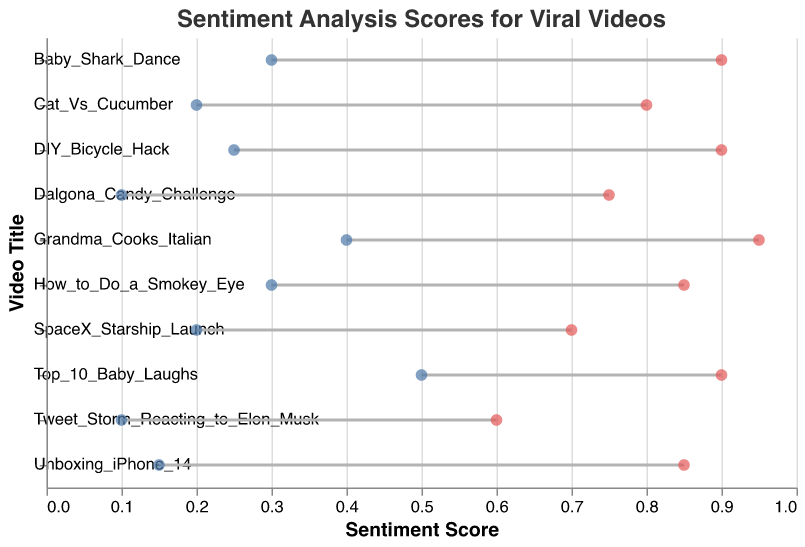Which video has the highest maximum sentiment score? Look for the highest point on the horizontal axis labeled as maximum sentiment scores, which is at 0.95. The corresponding video title is "Grandma Cooks Italian".
Answer: Grandma Cooks Italian What is the sentiment score range for the video "Unboxing iPhone 14" on YouTube? Locate "Unboxing iPhone 14" on the y-axis and note the minimum sentiment score (0.15) and the maximum sentiment score (0.85). The range is from 0.15 to 0.85.
Answer: 0.15 to 0.85 How many videos have a maximum sentiment score above 0.9? Identify all points on the horizontal axis for maximum sentiment score that are greater than 0.9. The videos are: "Grandma Cooks Italian" with a score of 0.95 and "Baby Shark Dance" with a score of 0.9.
Answer: 2 Which platform hosts the video with the smallest range in sentiment scores? Calculate the range (maximum minus minimum) for each video. "Tweet Storm Reacting to Elon Musk" on Twitter has a range of 0.6 - 0.1 = 0.5, which is the smallest.
Answer: Twitter Compare the sentiment score ranges of "DIY Bicycle Hack" on Instagram and "SpaceX Starship Launch" on Twitter. Which has a wider range? Calculate the range for both videos. "DIY Bicycle Hack" has a range of 0.9 - 0.25 = 0.65, and "SpaceX Starship Launch" has a range of 0.7 - 0.2 = 0.5. "DIY Bicycle Hack" has a wider range.
Answer: DIY Bicycle Hack Which video has the highest minimum sentiment score? Look for the highest point on the horizontal axis labeled as minimum sentiment scores, which is at 0.5. The corresponding video title is "Top 10 Baby Laughs".
Answer: Top 10 Baby Laughs Find the average of the minimum sentiment scores for YouTube videos. Sum the minimum sentiment scores of "Unboxing iPhone 14" (0.15) and "Baby Shark Dance" (0.3), then divide by the number of videos: (0.15 + 0.3) / 2 = 0.225.
Answer: 0.225 What is the difference in maximum sentiment score between "Dalgona Candy Challenge" on TikTok and "How to Do a Smokey Eye" on Instagram? Subtract the maximum sentiment score of "Dalgona Candy Challenge" (0.75) from "How to Do a Smokey Eye" (0.85): 0.85 - 0.75 = 0.1.
Answer: 0.1 Which platform has the most videos with a minimum sentiment score of at least 0.3? Count the number of videos on each platform with minimum sentiment scores of at least 0.3. Instagram ("How to Do a Smokey Eye" and "DIY Bicycle Hack"), Facebook ("Grandma Cooks Italian" and "Top 10 Baby Laughs"), and YouTube ("Baby Shark Dance") all have videos with minimum sentiment scores of 0.3 or higher, with Instagram and Facebook both hosting 2 videos each.
Answer: Instagram and Facebook 